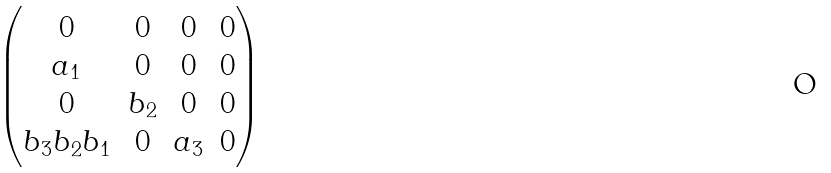Convert formula to latex. <formula><loc_0><loc_0><loc_500><loc_500>\begin{pmatrix} 0 & 0 & 0 & 0 \\ a _ { 1 } & 0 & 0 & 0 \\ 0 & b _ { 2 } & 0 & 0 \\ b _ { 3 } b _ { 2 } b _ { 1 } & 0 & a _ { 3 } & 0 \end{pmatrix}</formula> 